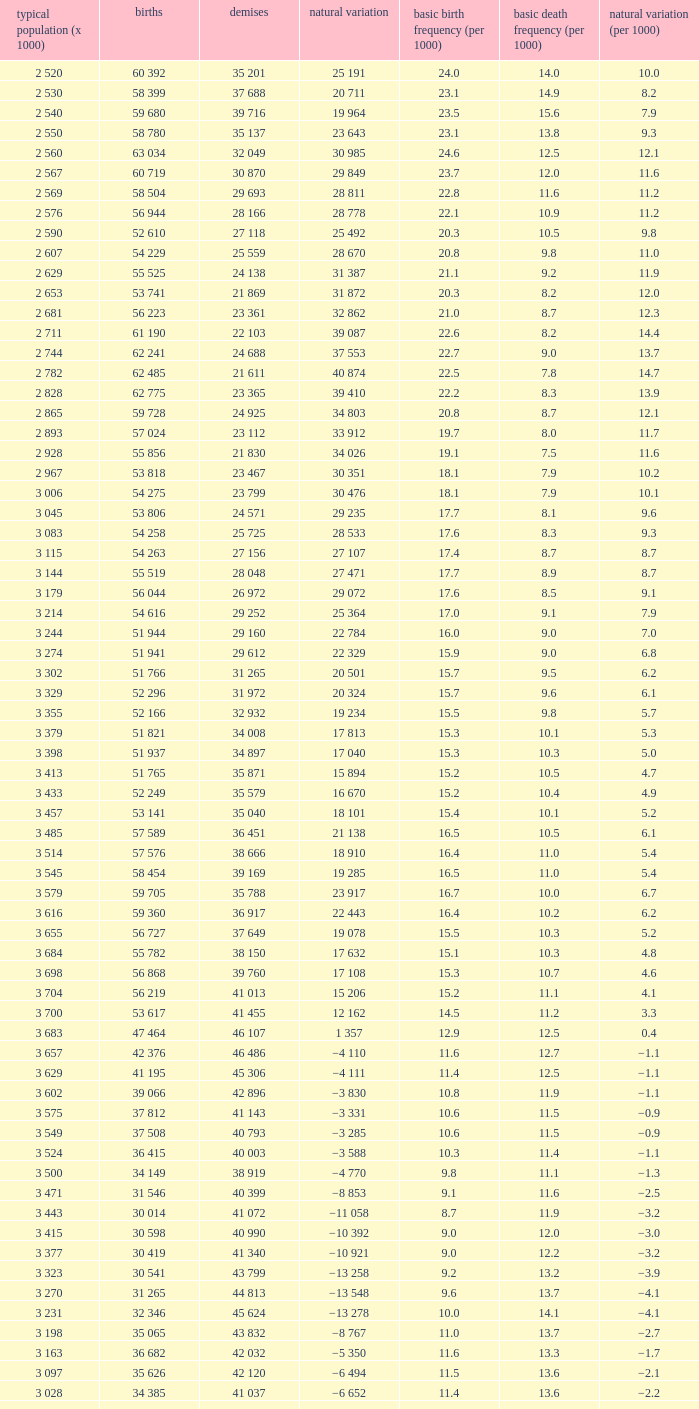Which Live births have a Natural change (per 1000) of 12.0? 53 741. 